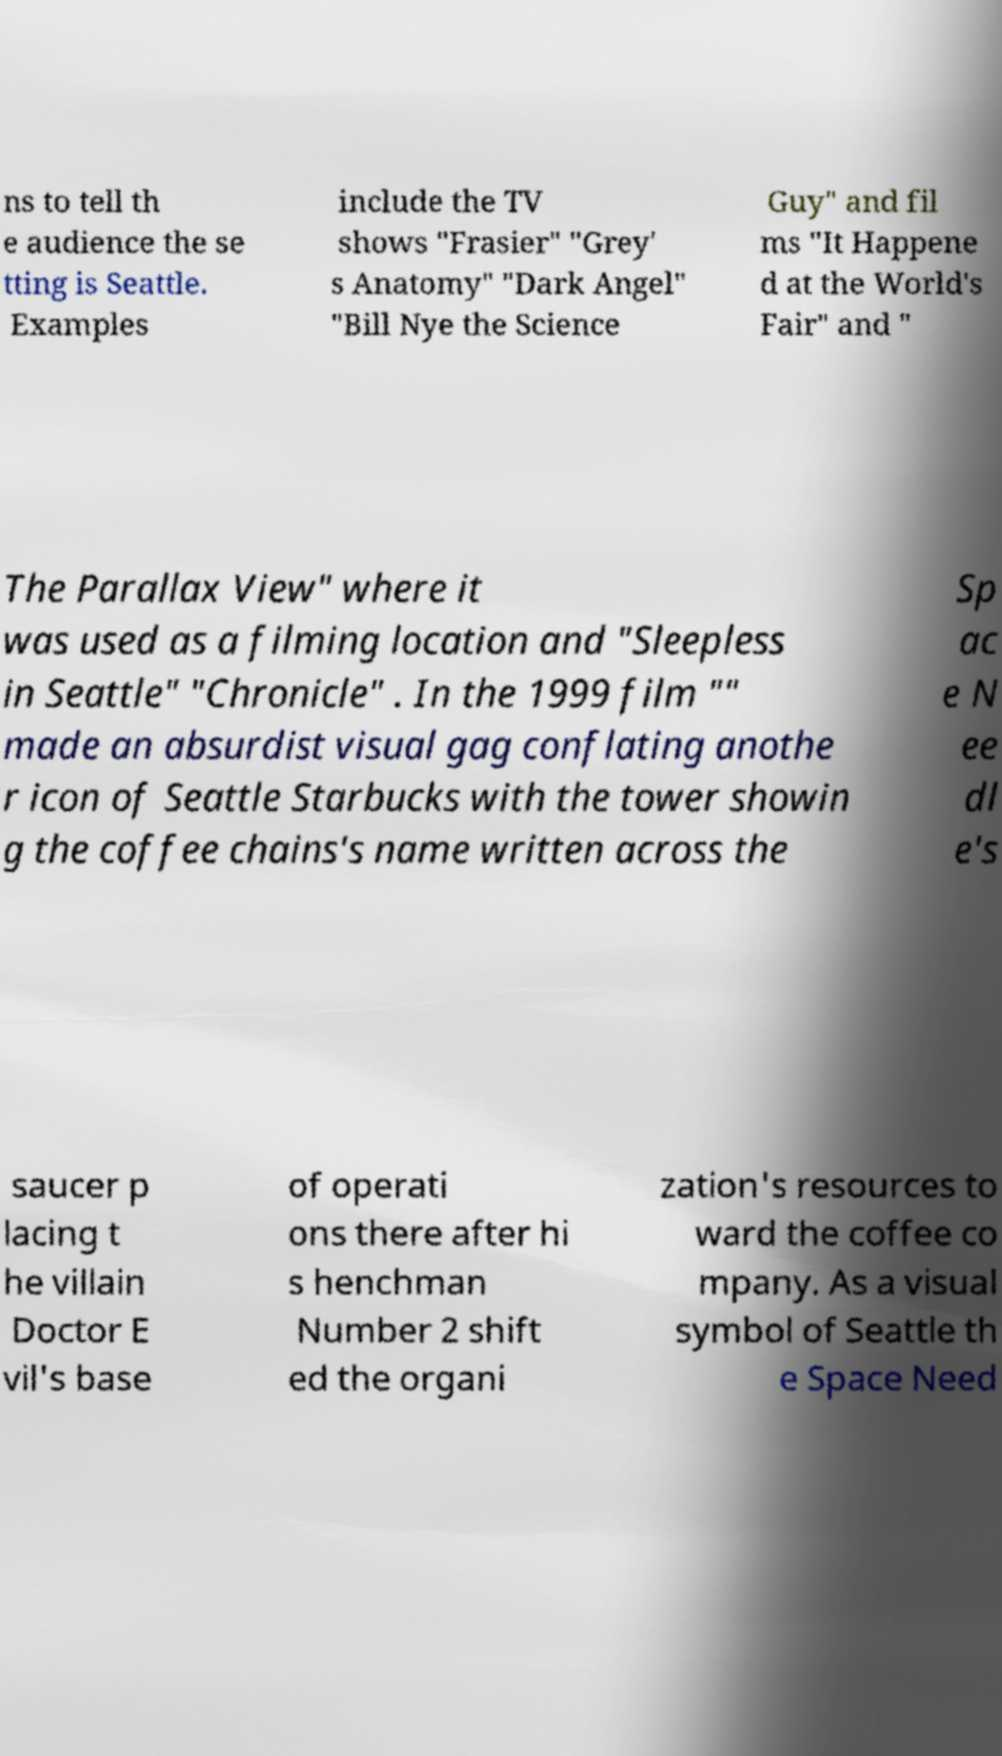Please read and relay the text visible in this image. What does it say? ns to tell th e audience the se tting is Seattle. Examples include the TV shows "Frasier" "Grey' s Anatomy" "Dark Angel" "Bill Nye the Science Guy" and fil ms "It Happene d at the World's Fair" and " The Parallax View" where it was used as a filming location and "Sleepless in Seattle" "Chronicle" . In the 1999 film "" made an absurdist visual gag conflating anothe r icon of Seattle Starbucks with the tower showin g the coffee chains's name written across the Sp ac e N ee dl e's saucer p lacing t he villain Doctor E vil's base of operati ons there after hi s henchman Number 2 shift ed the organi zation's resources to ward the coffee co mpany. As a visual symbol of Seattle th e Space Need 